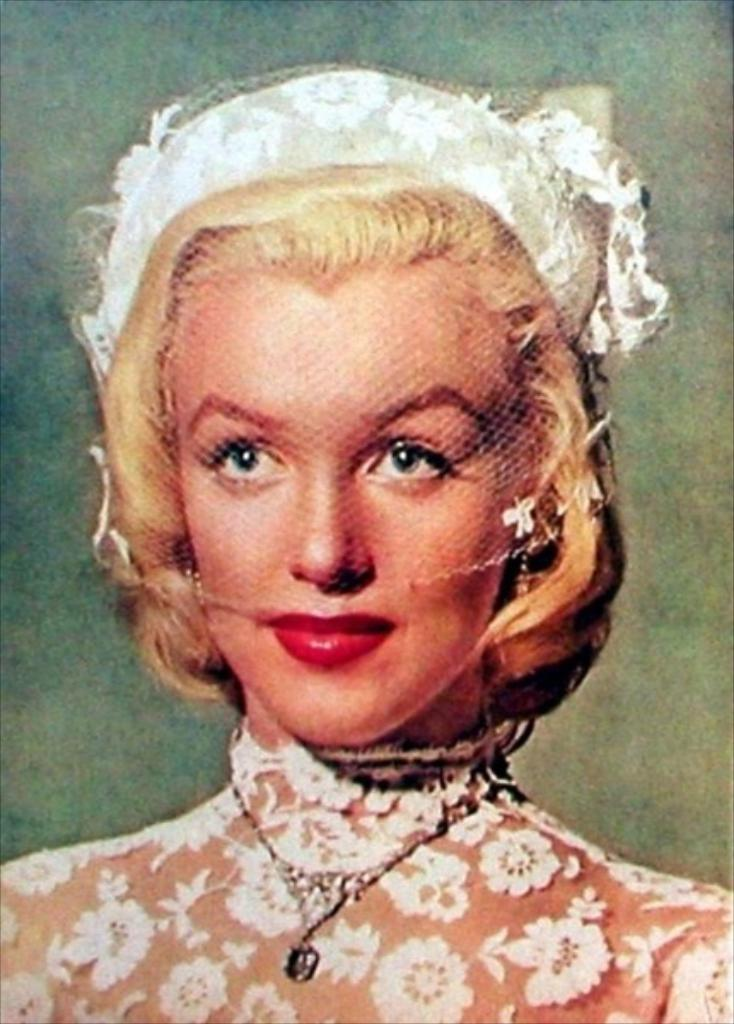Who is the main subject in the picture? There is a woman in the picture. What is the woman wearing on her body? The woman is wearing a dress. Are there any accessories visible on the woman? Yes, the woman is wearing a necklace. Is there any headwear visible on the woman? Yes, the woman is wearing a cap. What type of degree does the woman have, as seen in the image? There is no indication of a degree in the image, as it only shows the woman wearing a dress, necklace, and cap. 